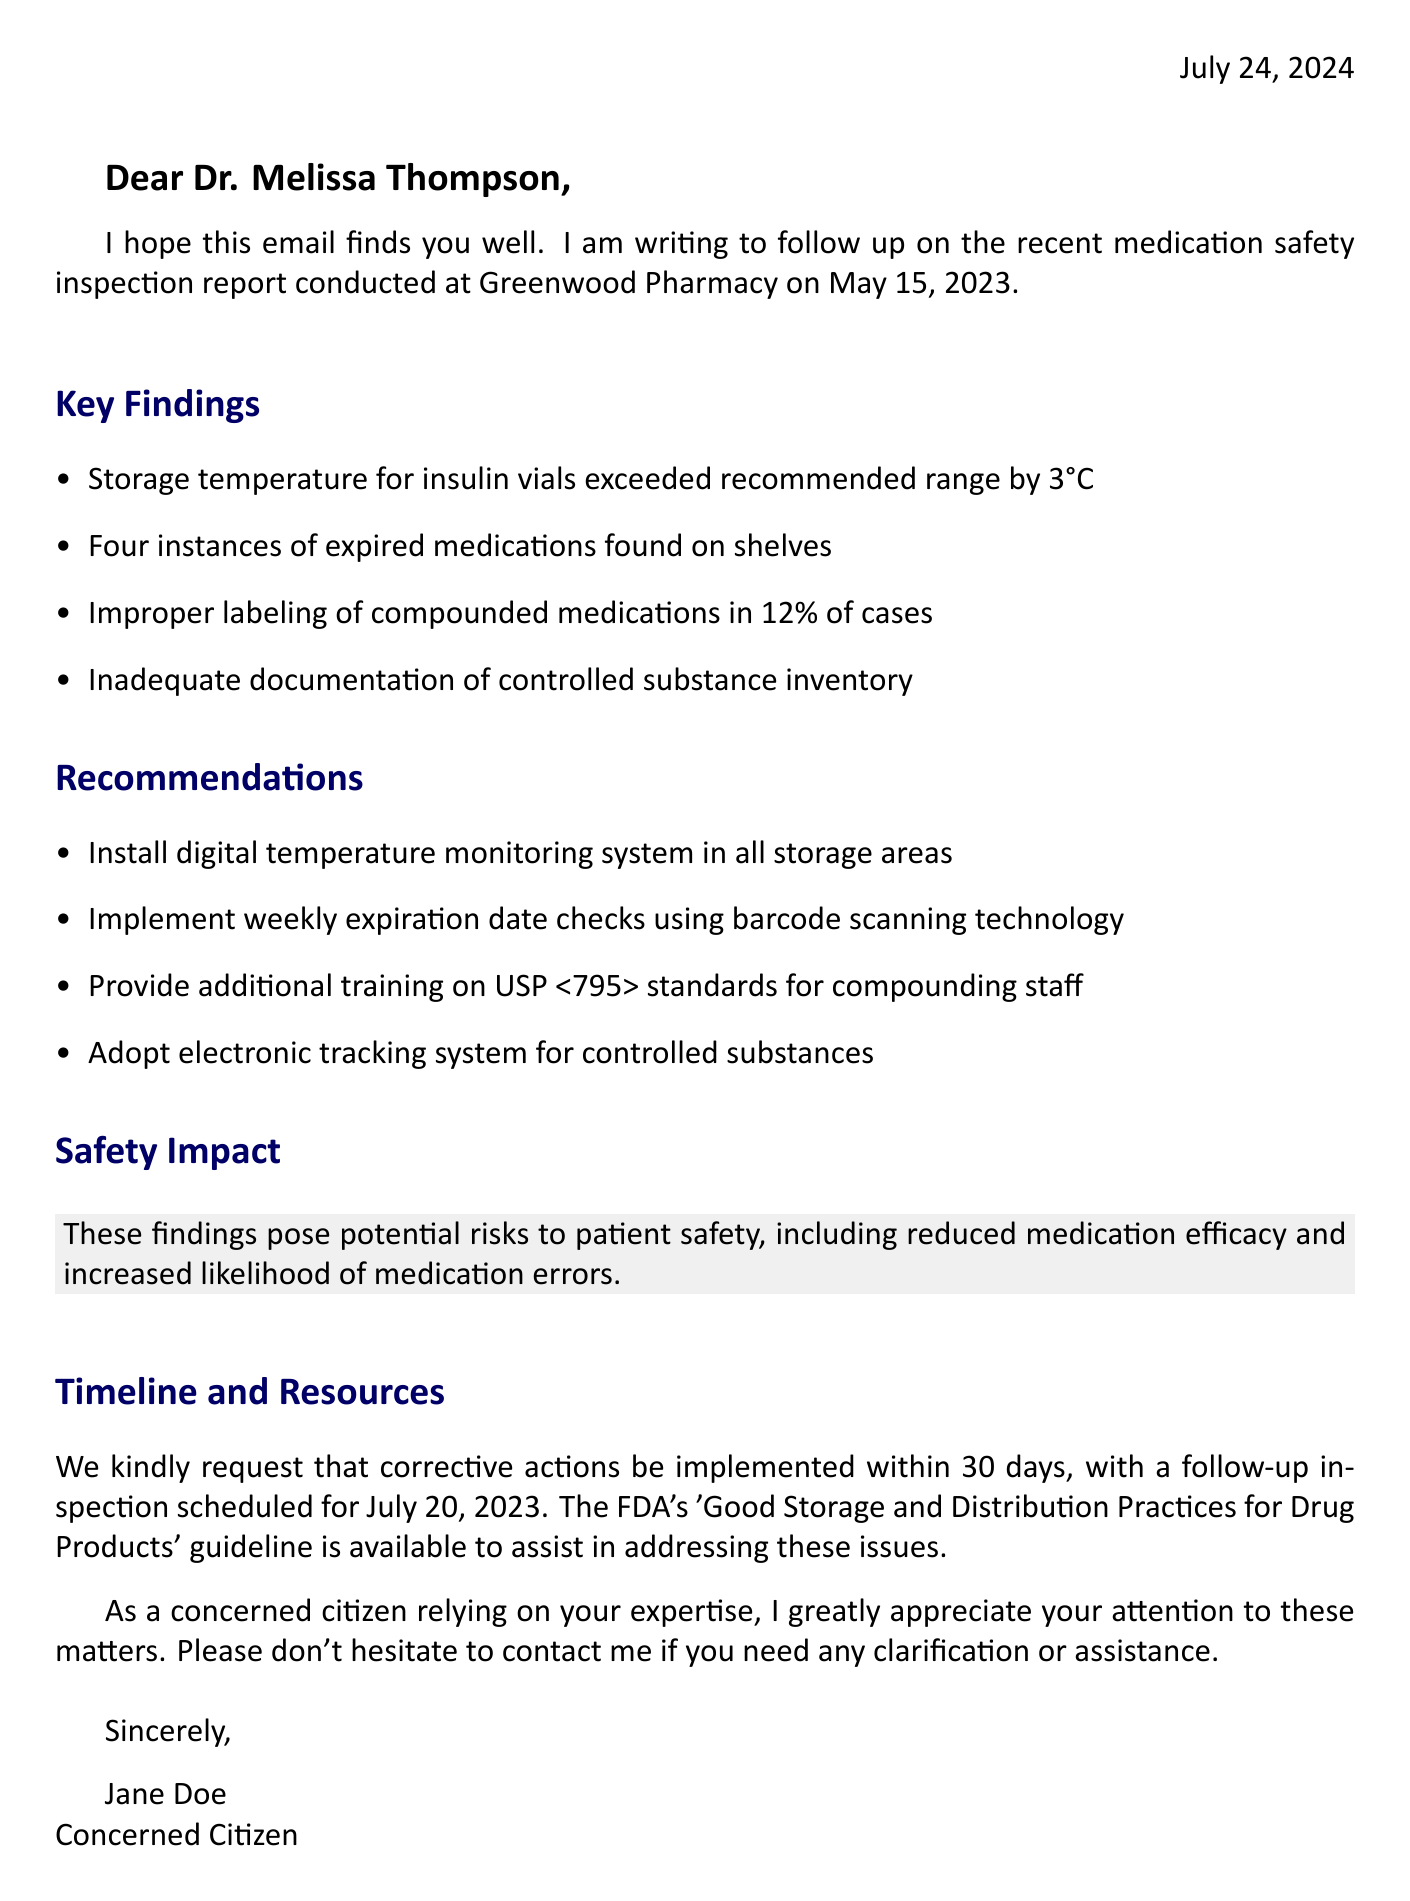What was the date of the inspection? The inspection at Greenwood Pharmacy was conducted on May 15, 2023.
Answer: May 15, 2023 How many instances of expired medications were found? The report noted that four instances of expired medications were found on shelves.
Answer: Four What temperature did the insulin storage exceed? The storage temperature for insulin vials exceeded the recommended range by 3°C.
Answer: 3°C What is one recommendation made for compounded medications? The report recommends providing additional training on USP <795> standards for compounding staff.
Answer: Additional training on USP <795> standards When is the follow-up inspection scheduled? The follow-up inspection is scheduled for July 20, 2023.
Answer: July 20, 2023 What is the safety impact of the findings? The findings pose potential risks to patient safety, including reduced medication efficacy and increased likelihood of medication errors.
Answer: Potential risks to patient safety What kind of system is recommended for controlled substances? The report recommends adopting an electronic tracking system for controlled substances.
Answer: Electronic tracking system Which guideline is suggested to assist in addressing the issues? The FDA's 'Good Storage and Distribution Practices for Drug Products' guideline is suggested.
Answer: FDA's 'Good Storage and Distribution Practices for Drug Products' guideline 